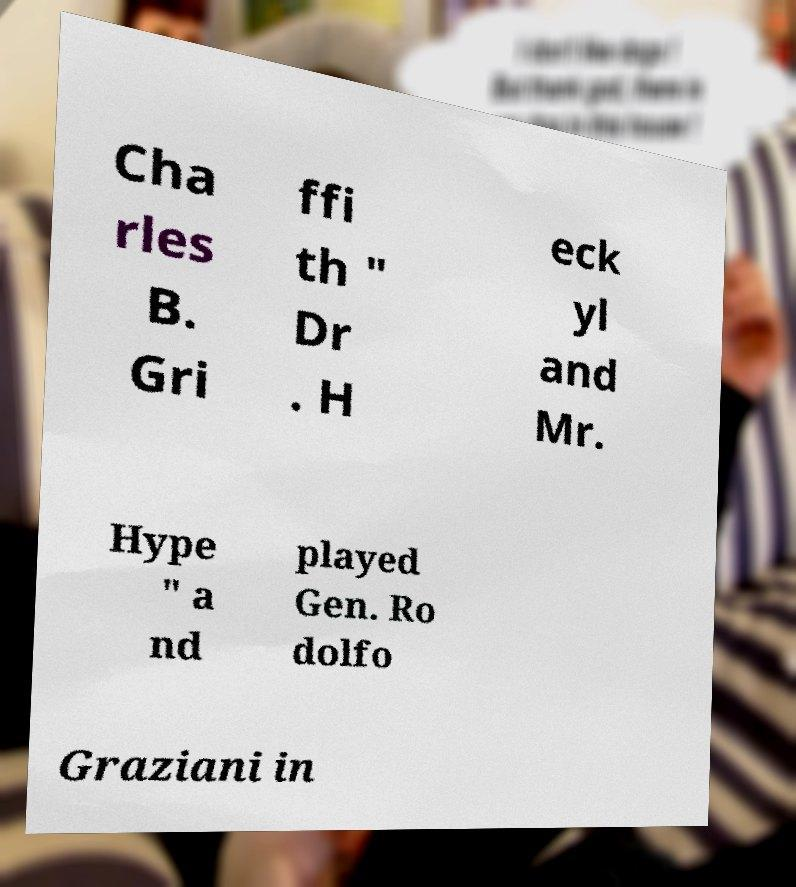Can you accurately transcribe the text from the provided image for me? Cha rles B. Gri ffi th " Dr . H eck yl and Mr. Hype " a nd played Gen. Ro dolfo Graziani in 